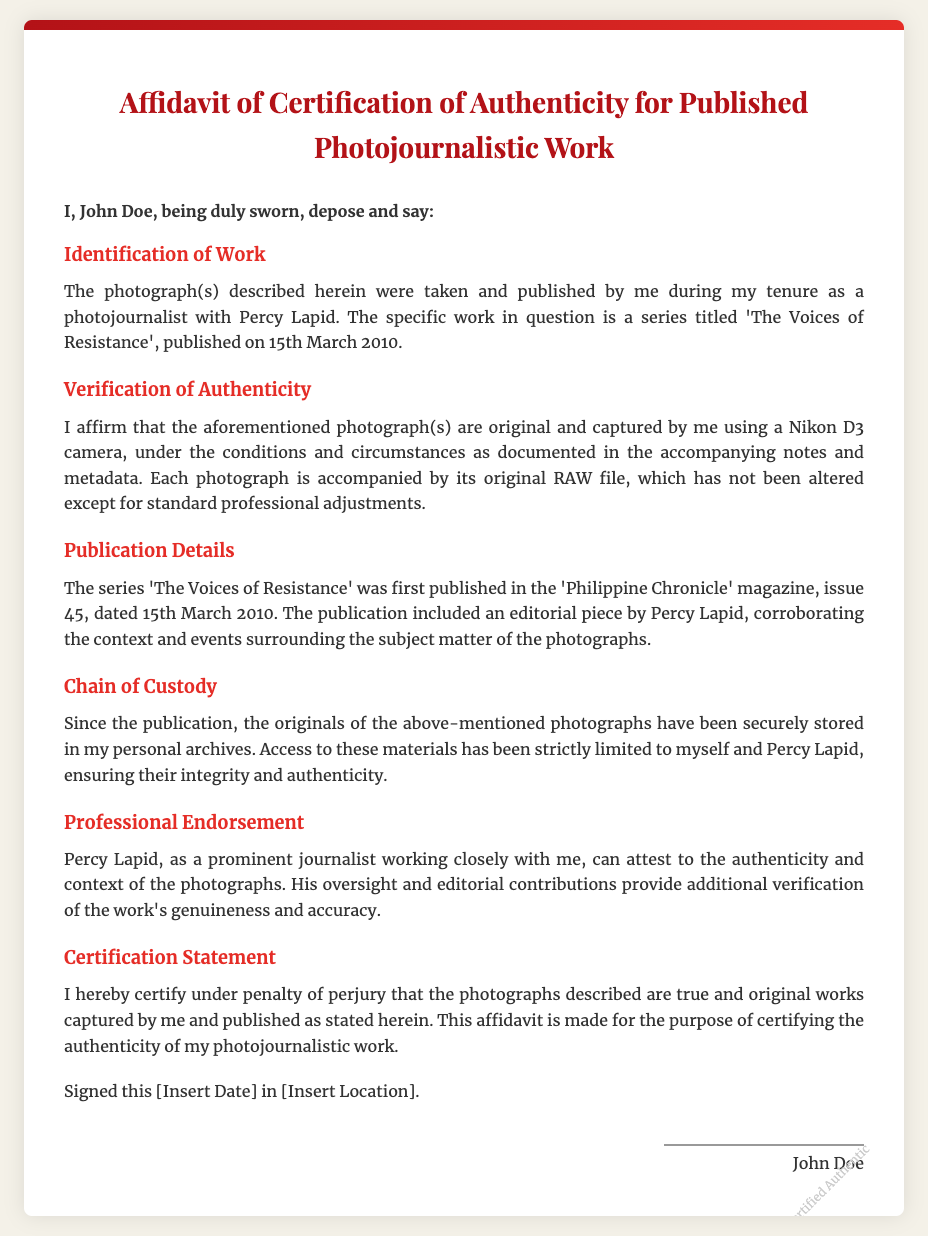What is the title of the work? The document mentions the title of the work as 'The Voices of Resistance'.
Answer: 'The Voices of Resistance' Who is the affiant? The affiant of the document is identified as John Doe.
Answer: John Doe What date was the work published? The document states the work was published on 15th March 2010.
Answer: 15th March 2010 What type of camera was used? The affidavit indicates that a Nikon D3 camera was used to capture the photographs.
Answer: Nikon D3 Which magazine published the series? The series 'The Voices of Resistance' was published in the 'Philippine Chronicle' magazine.
Answer: Philippine Chronicle Who can attest to the authenticity of the photographs? Percy Lapid can attest to the authenticity of the photographs.
Answer: Percy Lapid What is the purpose of the affidavit? The affidavit is made for certifying the authenticity of the photojournalistic work.
Answer: Certifying the authenticity What is the status of the original photographs? The originals of the photographs have been securely stored in personal archives.
Answer: Securely stored What editorial piece accompanied the publication? An editorial piece by Percy Lapid accompanied the publication.
Answer: Editorial piece by Percy Lapid 